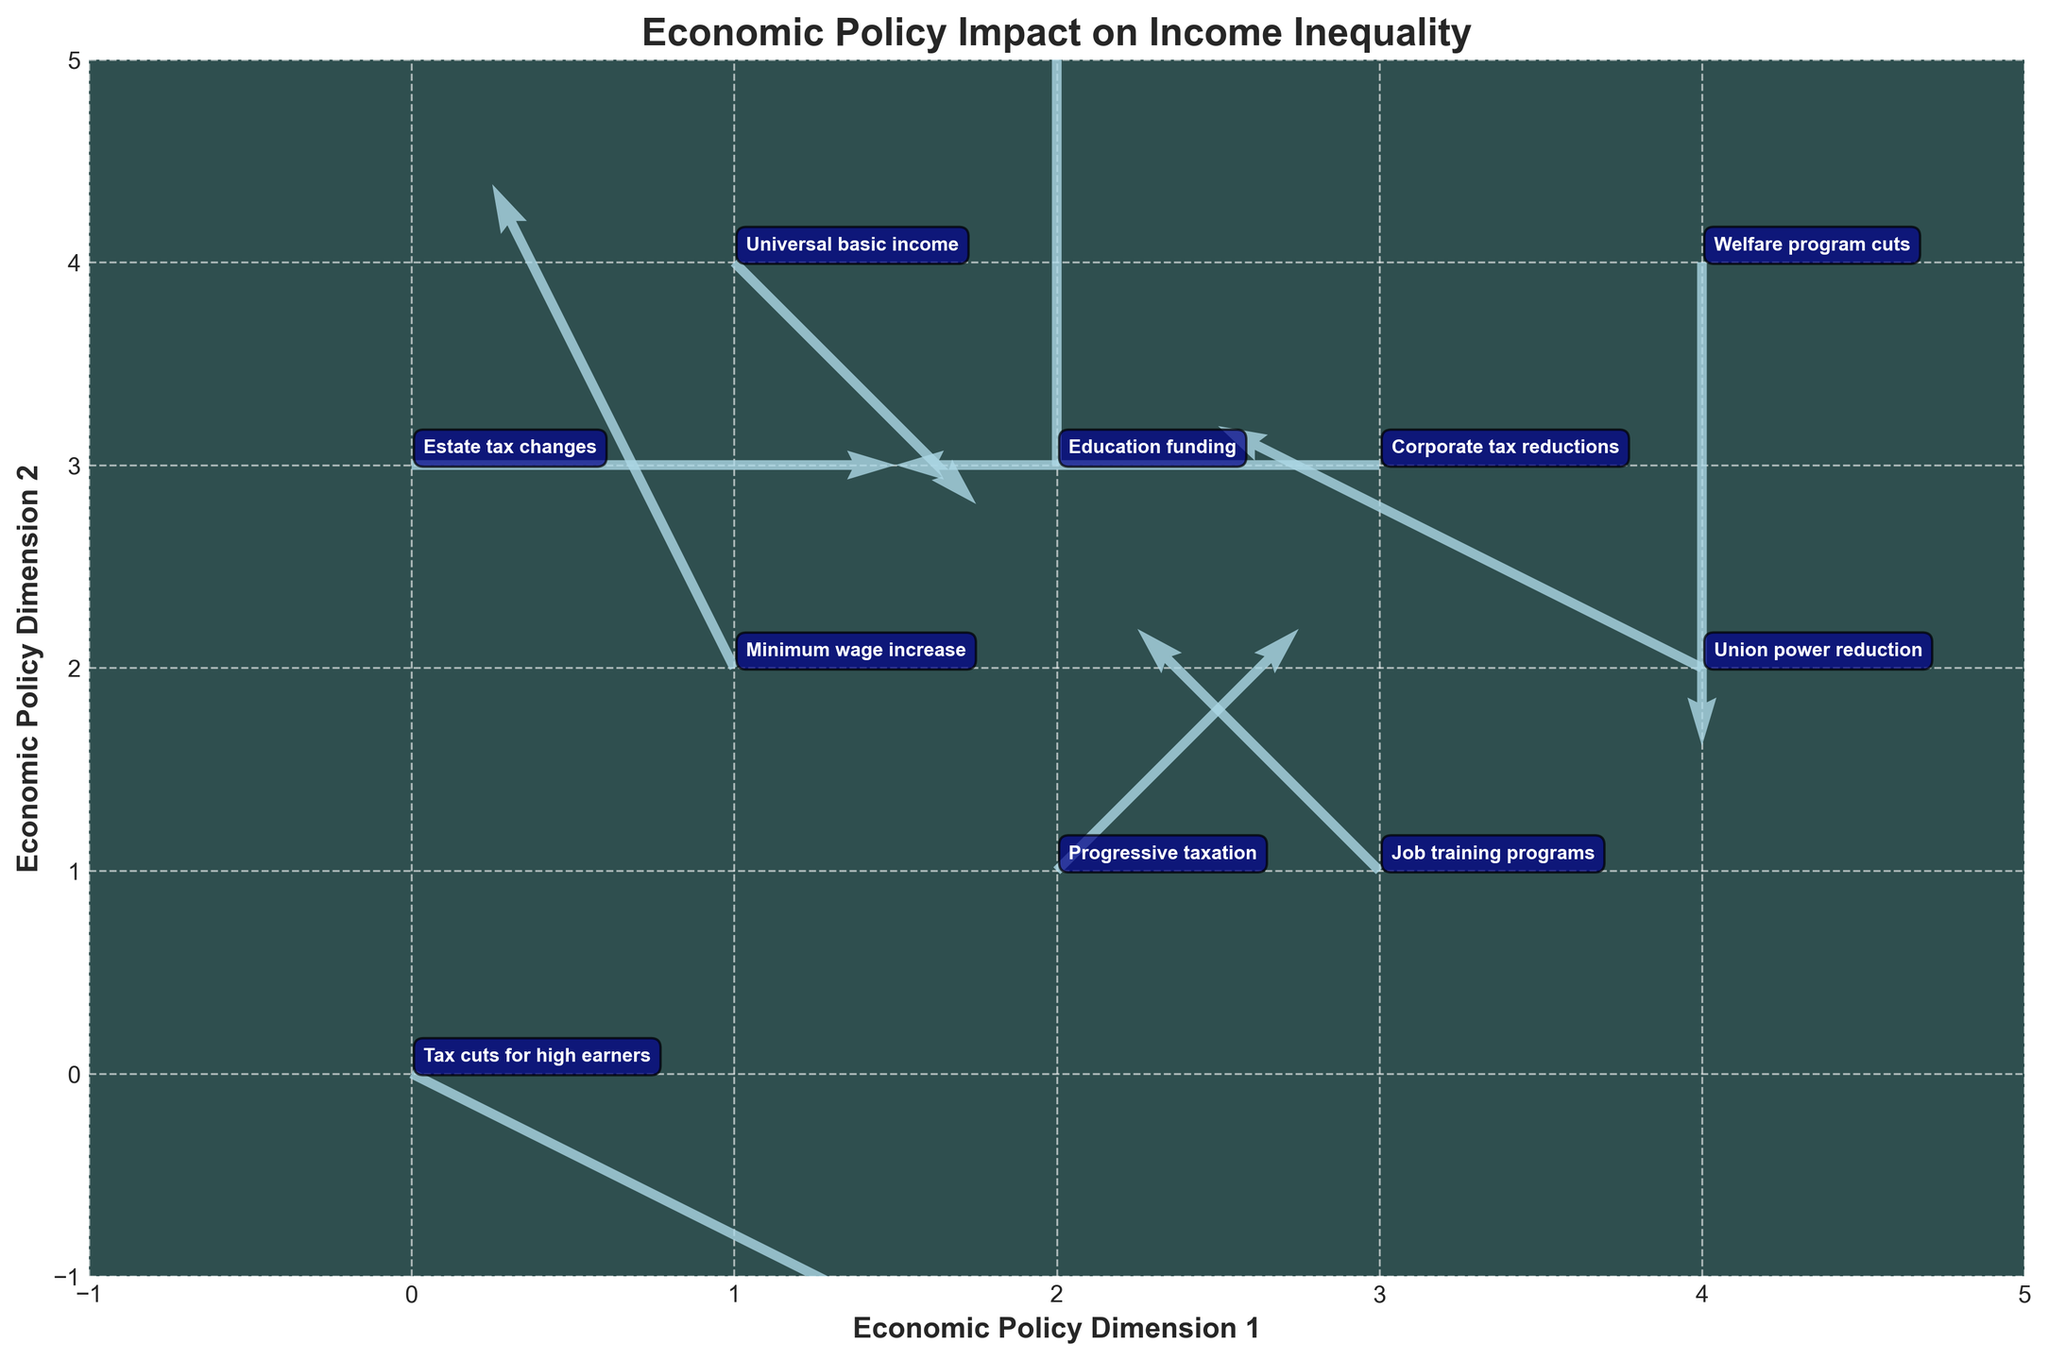How many economic policies are represented in the plot? Count the number of labeled vectors/annotations in the plot. Each labeled vector is an economic policy. There are 10 vectors in total.
Answer: 10 What is the title of the plot? Look in the top part of the plot for the title text. It is usually displayed prominently. The title is "Economic Policy Impact on Income Inequality."
Answer: Economic Policy Impact on Income Inequality Which policy shows a reduction in the first economic policy dimension but no change in the second dimension? Look for the vector that points left (reduction in the first dimension) and has no vertical movement. The label for this vector is "Corporate tax reductions."
Answer: Corporate tax reductions Which policy increases both dimensions of the economic policy? Identify the vector that points up and to the right, indicating an increase in both dimensions. The label for this vector is "Progressive taxation."
Answer: Progressive taxation What are the x and y axis labels? Check the labels adjacent to the horizontal and vertical axis lines. The x-axis label is "Economic Policy Dimension 1" and the y-axis label is "Economic Policy Dimension 2."
Answer: Economic Policy Dimension 1, Economic Policy Dimension 2 Which policy is located at (1, 2) and in what direction does it move? Find the vector originating at the coordinates (1, 2). The vector here, labeled "Minimum wage increase," moves up and to the left.
Answer: Minimum wage increase, up and to the left Which policy has no impact on the second economic policy dimension but increases the first dimension? Look for the vector staying on the same vertical level but pointing to the right. This is associated with "Estate tax changes."
Answer: Estate tax changes How many policies result in a reduction in income inequality in the first economic policy dimension? Count the vectors pointing left (negative direction in the first dimension). There are 4 such vectors: "Minimum wage increase," "Corporate tax reductions," "Union power reduction," and "Job training programs."
Answer: 4 Which policy shows an upward movement in both economic policy dimensions and is located at (2, 3)? Identify the vector that originates from (2, 3) and moves upwards. This is labeled "Education funding."
Answer: Education funding Between "Tax cuts for high earners" and "Union power reduction," which policy is more impactful in reducing the first economic policy dimension? Compare the leftward movement of vectors for both policies. "Union power reduction" has a greater leftward movement than "Tax cuts for high earners."
Answer: Union power reduction 